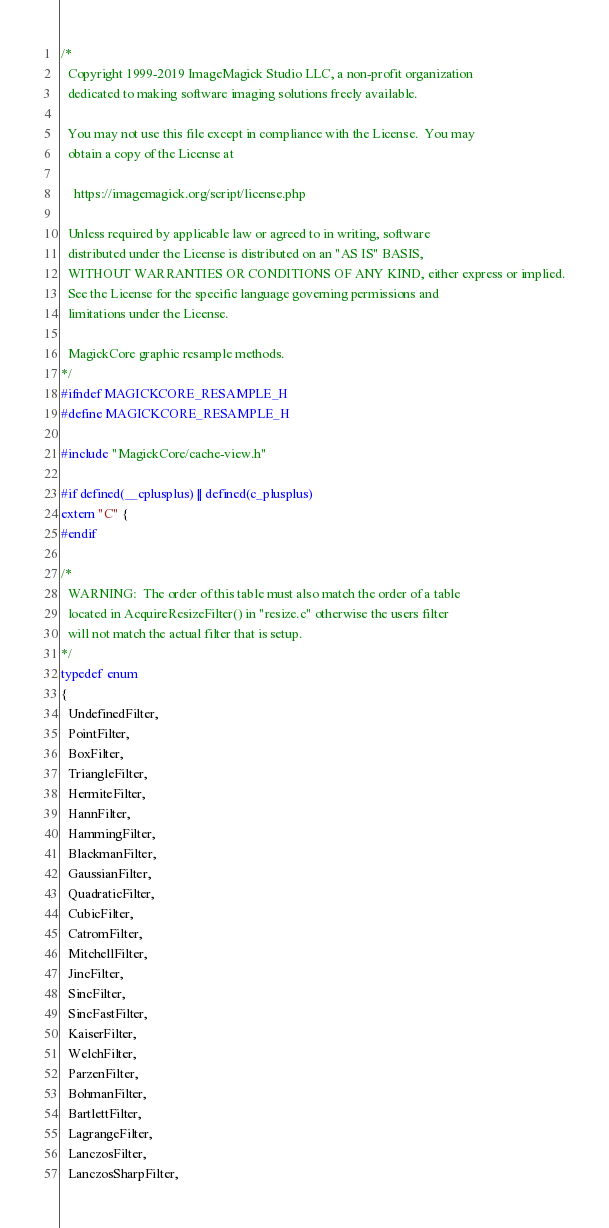Convert code to text. <code><loc_0><loc_0><loc_500><loc_500><_C_>/*
  Copyright 1999-2019 ImageMagick Studio LLC, a non-profit organization
  dedicated to making software imaging solutions freely available.
  
  You may not use this file except in compliance with the License.  You may
  obtain a copy of the License at
  
    https://imagemagick.org/script/license.php
  
  Unless required by applicable law or agreed to in writing, software
  distributed under the License is distributed on an "AS IS" BASIS,
  WITHOUT WARRANTIES OR CONDITIONS OF ANY KIND, either express or implied.
  See the License for the specific language governing permissions and
  limitations under the License.

  MagickCore graphic resample methods.
*/
#ifndef MAGICKCORE_RESAMPLE_H
#define MAGICKCORE_RESAMPLE_H

#include "MagickCore/cache-view.h"

#if defined(__cplusplus) || defined(c_plusplus)
extern "C" {
#endif

/*
  WARNING:  The order of this table must also match the order of a table
  located in AcquireResizeFilter() in "resize.c" otherwise the users filter
  will not match the actual filter that is setup.
*/
typedef enum
{
  UndefinedFilter,
  PointFilter,
  BoxFilter,
  TriangleFilter,
  HermiteFilter,
  HannFilter,
  HammingFilter,
  BlackmanFilter,
  GaussianFilter,
  QuadraticFilter,
  CubicFilter,
  CatromFilter,
  MitchellFilter,
  JincFilter,
  SincFilter,
  SincFastFilter,
  KaiserFilter,
  WelchFilter,
  ParzenFilter,
  BohmanFilter,
  BartlettFilter,
  LagrangeFilter,
  LanczosFilter,
  LanczosSharpFilter,</code> 